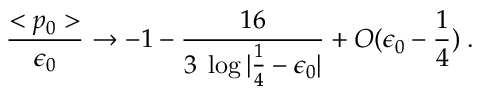Convert formula to latex. <formula><loc_0><loc_0><loc_500><loc_500>{ \frac { < p _ { 0 } > } { \epsilon _ { 0 } } } \rightarrow - 1 - { \frac { 1 6 } { 3 \, \log | \frac { 1 } { 4 } - \epsilon _ { 0 } | } } + O ( \epsilon _ { 0 } - \frac { 1 } { 4 } ) \, .</formula> 